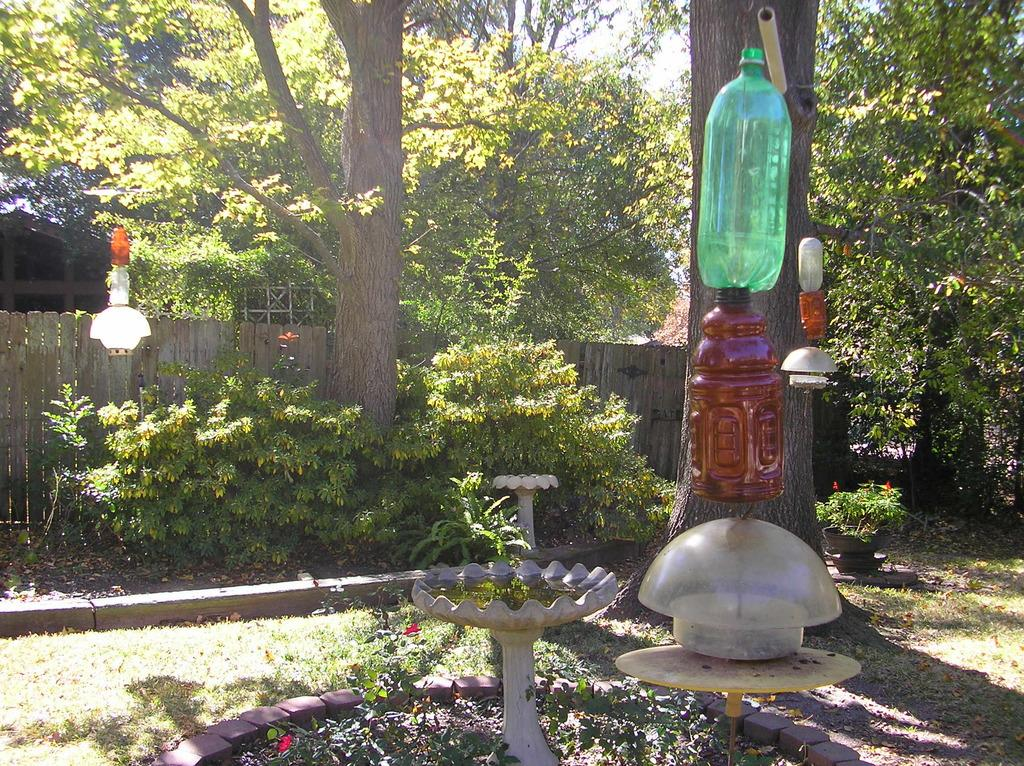What is hanging on the tree in the image? Bottles are hanged on a tree in the image. What can be seen in the middle of the image? There is a fountain in the middle of the image. What type of vegetation is present in the image? Plants are present in the image. What can be seen in the background of the image? There are trees and a wooden fencing in the background of the image. What type of pen is the lawyer using to write in the image? There is no lawyer or pen present in the image. Can you tell me how many ants are crawling on the fountain in the image? There are no ants present in the image; the focus is on the bottles hanging on the tree, the fountain, plants, trees, and wooden fencing in the background. 